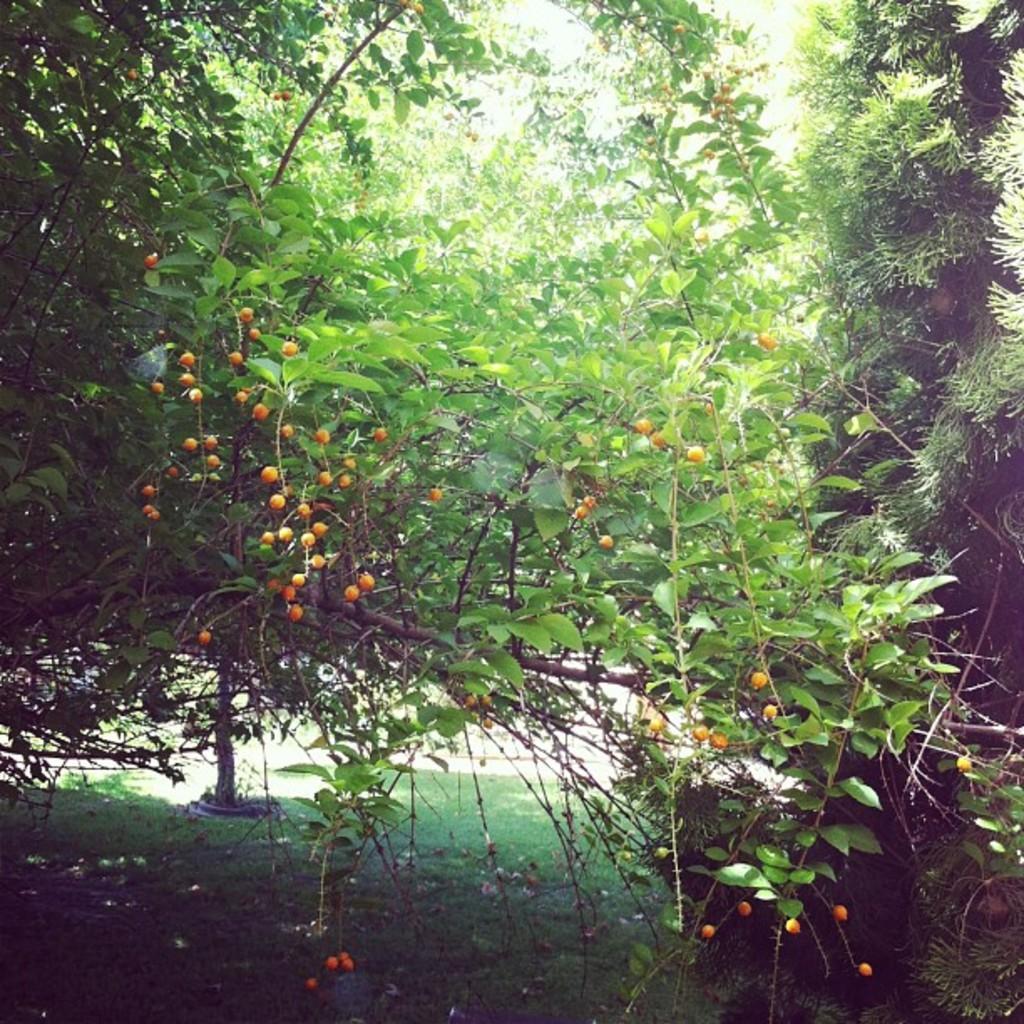Please provide a concise description of this image. In this image there are trees and we can see fruits to it. At the bottom there is grass. 